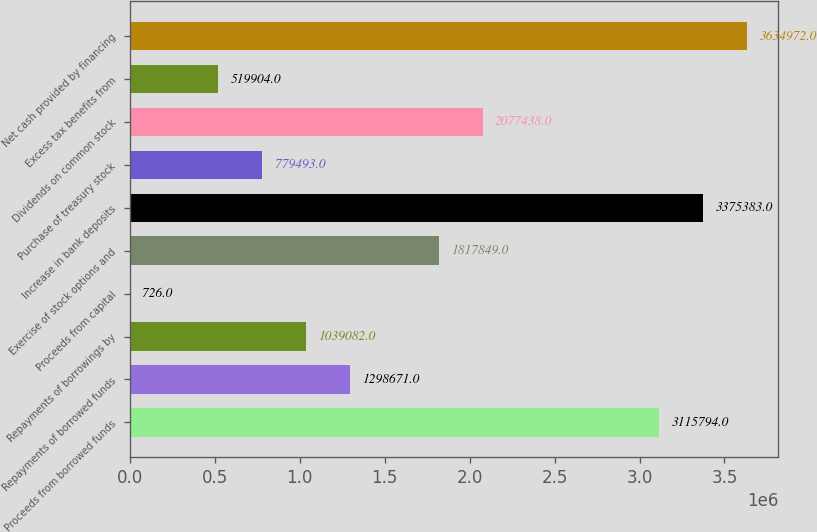Convert chart to OTSL. <chart><loc_0><loc_0><loc_500><loc_500><bar_chart><fcel>Proceeds from borrowed funds<fcel>Repayments of borrowed funds<fcel>Repayments of borrowings by<fcel>Proceeds from capital<fcel>Exercise of stock options and<fcel>Increase in bank deposits<fcel>Purchase of treasury stock<fcel>Dividends on common stock<fcel>Excess tax benefits from<fcel>Net cash provided by financing<nl><fcel>3.11579e+06<fcel>1.29867e+06<fcel>1.03908e+06<fcel>726<fcel>1.81785e+06<fcel>3.37538e+06<fcel>779493<fcel>2.07744e+06<fcel>519904<fcel>3.63497e+06<nl></chart> 